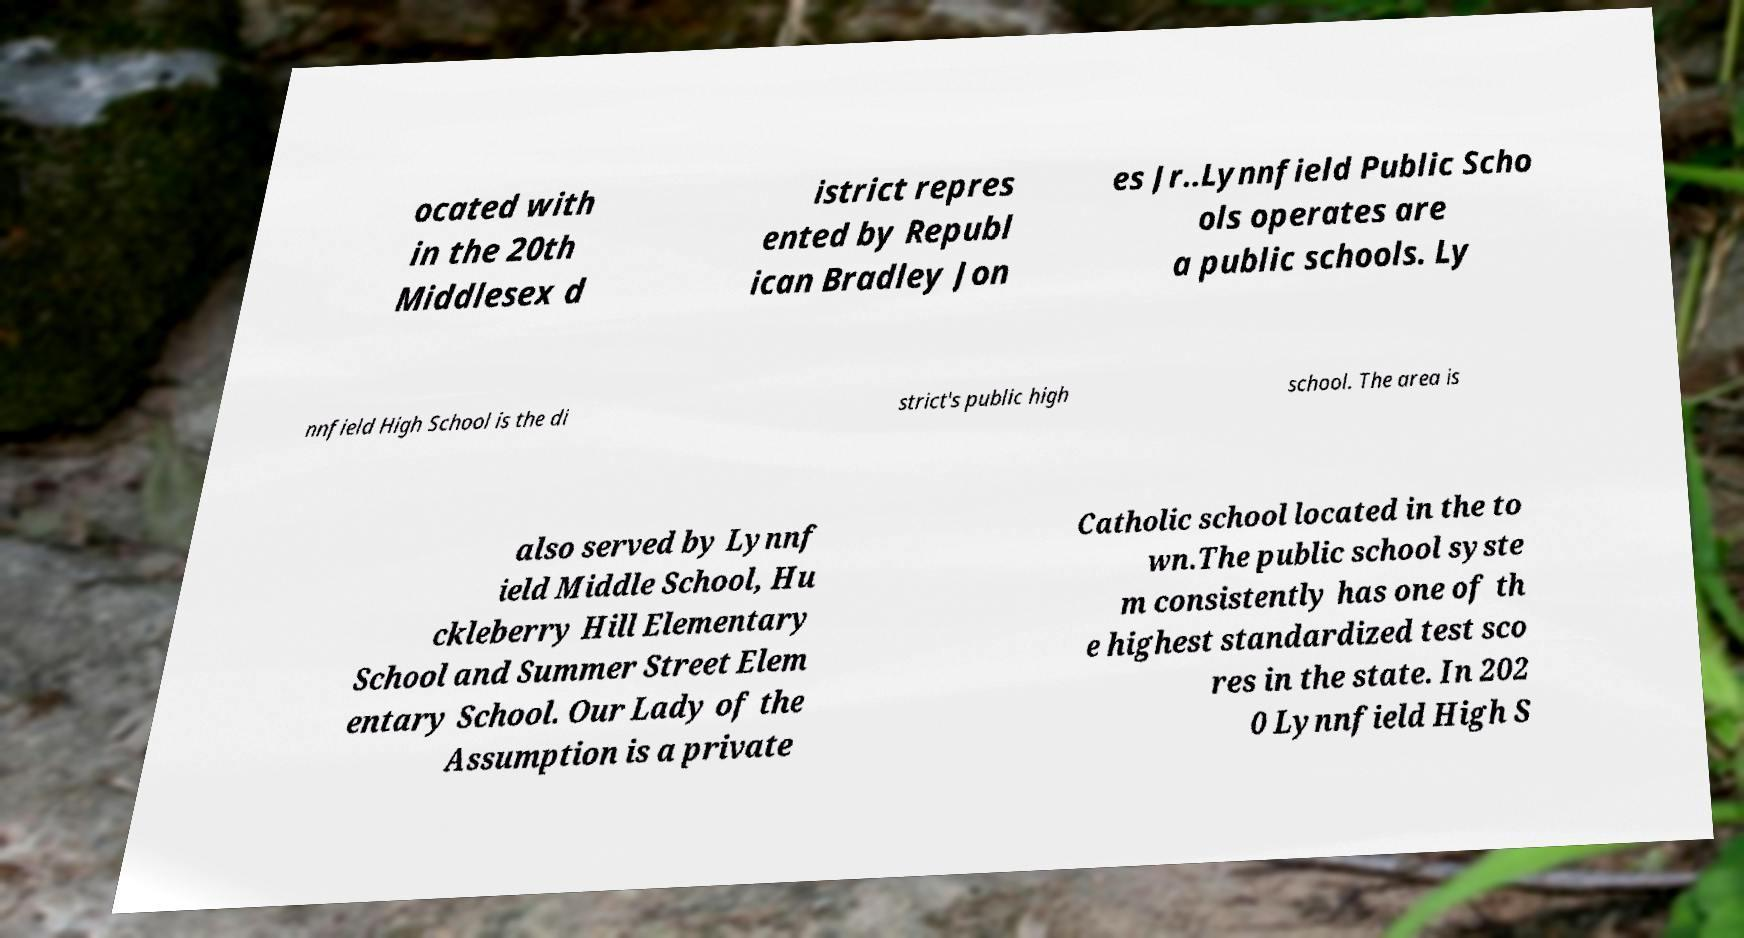Please identify and transcribe the text found in this image. ocated with in the 20th Middlesex d istrict repres ented by Republ ican Bradley Jon es Jr..Lynnfield Public Scho ols operates are a public schools. Ly nnfield High School is the di strict's public high school. The area is also served by Lynnf ield Middle School, Hu ckleberry Hill Elementary School and Summer Street Elem entary School. Our Lady of the Assumption is a private Catholic school located in the to wn.The public school syste m consistently has one of th e highest standardized test sco res in the state. In 202 0 Lynnfield High S 